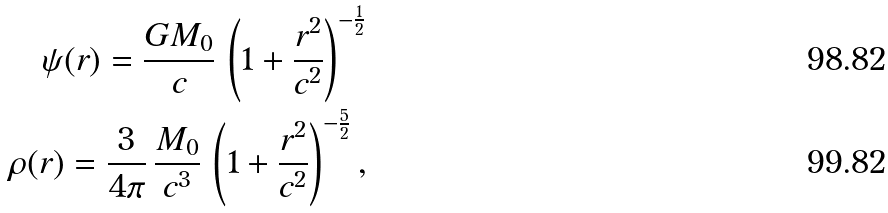<formula> <loc_0><loc_0><loc_500><loc_500>\psi ( r ) = \frac { G M _ { 0 } } { c } \, \left ( 1 + \frac { r ^ { 2 } } { c ^ { 2 } } \right ) ^ { - \frac { 1 } { 2 } } \\ \rho ( r ) = \frac { 3 } { 4 \pi } \, \frac { M _ { 0 } } { c ^ { 3 } } \, \left ( 1 + \frac { r ^ { 2 } } { c ^ { 2 } } \right ) ^ { - \frac { 5 } { 2 } } ,</formula> 